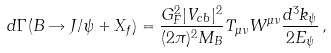<formula> <loc_0><loc_0><loc_500><loc_500>d \Gamma { ( B \rightarrow J / \psi + X _ { f } ) } = \frac { G _ { F } ^ { 2 } | V _ { c b } | ^ { 2 } } { ( 2 \pi ) ^ { 2 } M _ { B } } T _ { \mu \nu } W ^ { \mu \nu } \frac { d ^ { 3 } { k } _ { \psi } } { 2 E _ { \psi } } \, ,</formula> 